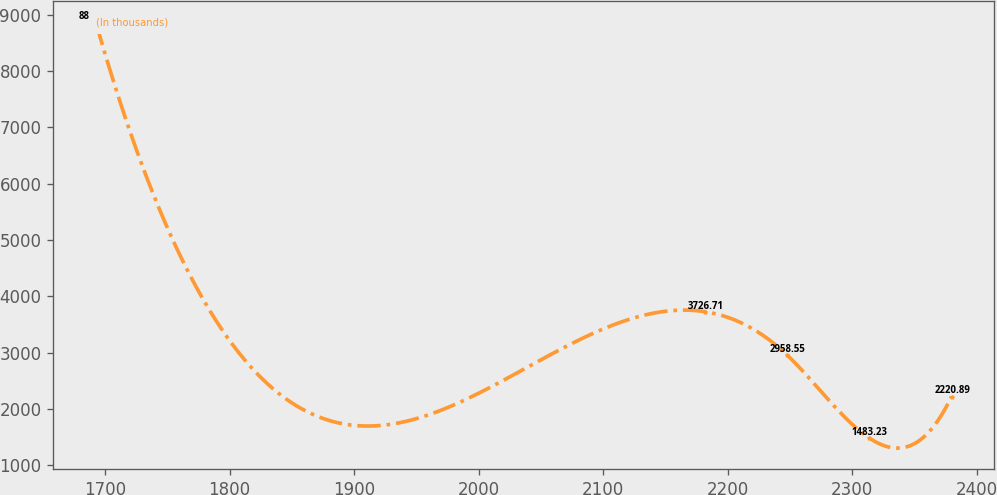Convert chart to OTSL. <chart><loc_0><loc_0><loc_500><loc_500><line_chart><ecel><fcel>(In thousands)<nl><fcel>1692.54<fcel>8859.79<nl><fcel>2181.69<fcel>3726.71<nl><fcel>2247.78<fcel>2958.55<nl><fcel>2313.87<fcel>1483.23<nl><fcel>2379.96<fcel>2220.89<nl></chart> 